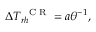Convert formula to latex. <formula><loc_0><loc_0><loc_500><loc_500>\Delta T _ { r h } ^ { C R } = a \theta ^ { - 1 } ,</formula> 